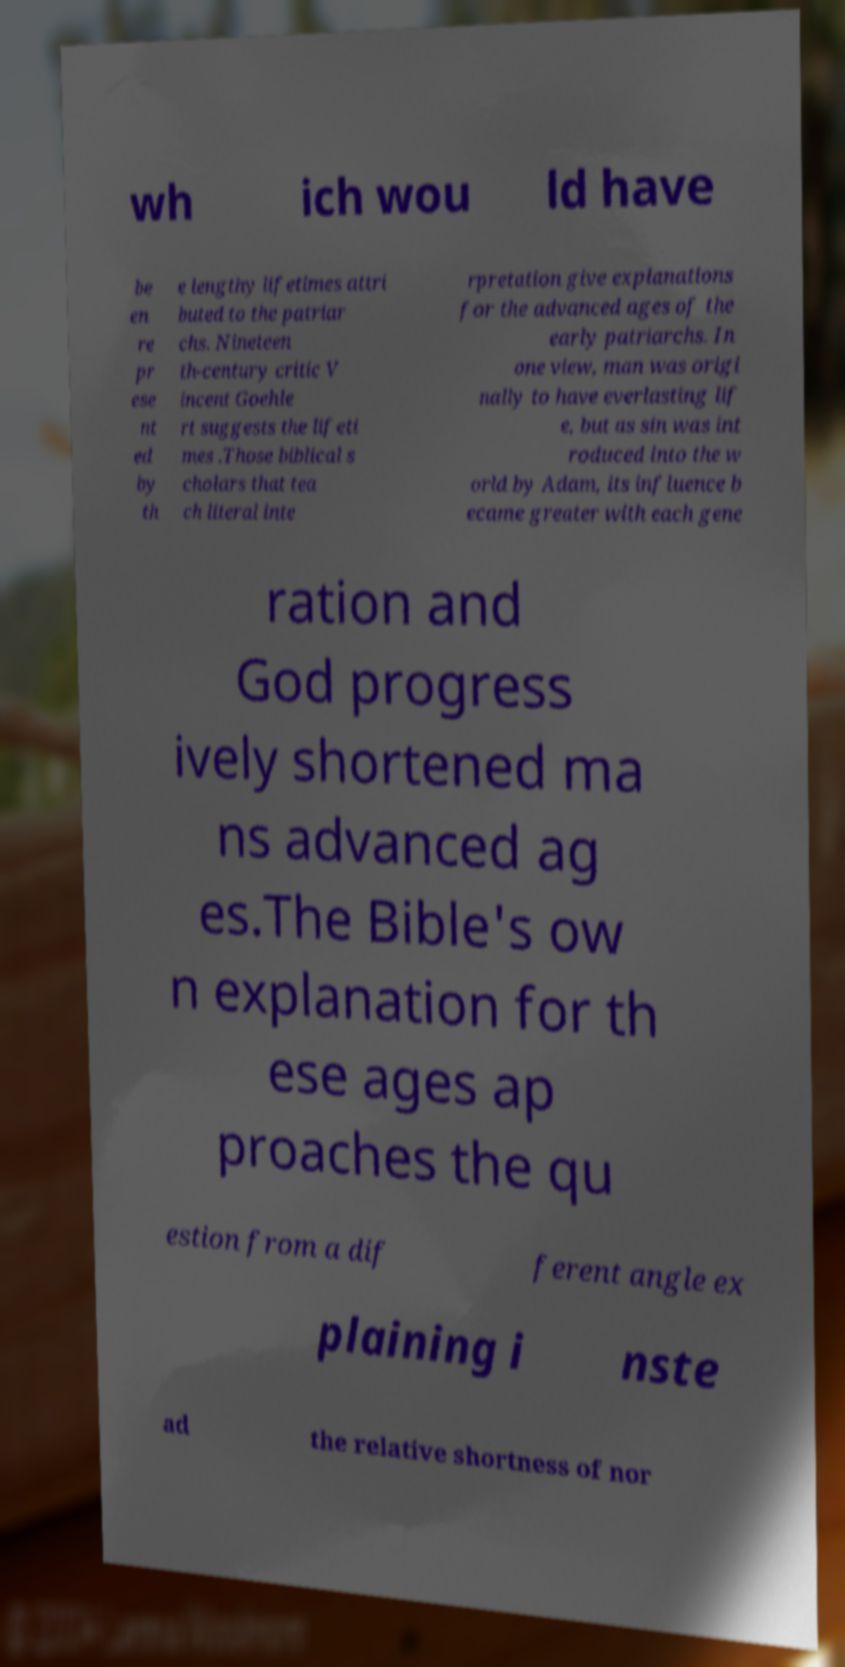There's text embedded in this image that I need extracted. Can you transcribe it verbatim? wh ich wou ld have be en re pr ese nt ed by th e lengthy lifetimes attri buted to the patriar chs. Nineteen th-century critic V incent Goehle rt suggests the lifeti mes .Those biblical s cholars that tea ch literal inte rpretation give explanations for the advanced ages of the early patriarchs. In one view, man was origi nally to have everlasting lif e, but as sin was int roduced into the w orld by Adam, its influence b ecame greater with each gene ration and God progress ively shortened ma ns advanced ag es.The Bible's ow n explanation for th ese ages ap proaches the qu estion from a dif ferent angle ex plaining i nste ad the relative shortness of nor 